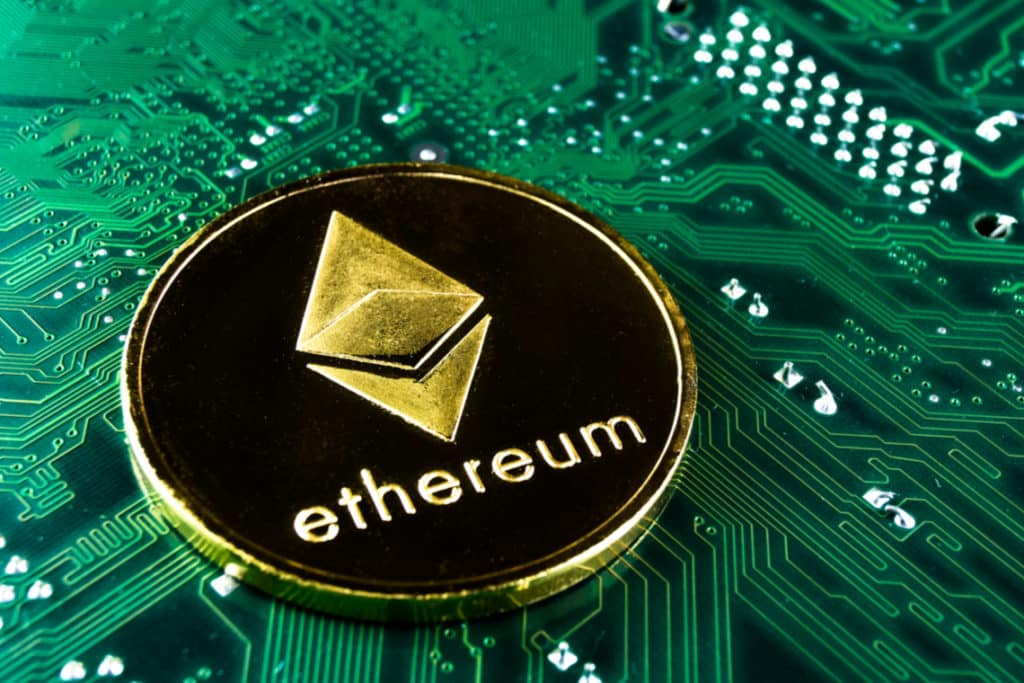In what ways can the relationship depicted in the image influence future technological developments? The depicted relationship in the image suggests that the future of technological development will likely see a tighter integration between blockchain technology and hardware advancements. As blockchain applications like Ethereum continue to grow, there will be increased demand for more efficient, powerful, and specialized hardware. Innovations in this space might include energy-efficient mining rigs, advancements in chip technology to handle faster and more secure transactions, and the development of decentralized storage solutions to support blockchain’s expanding needs. 